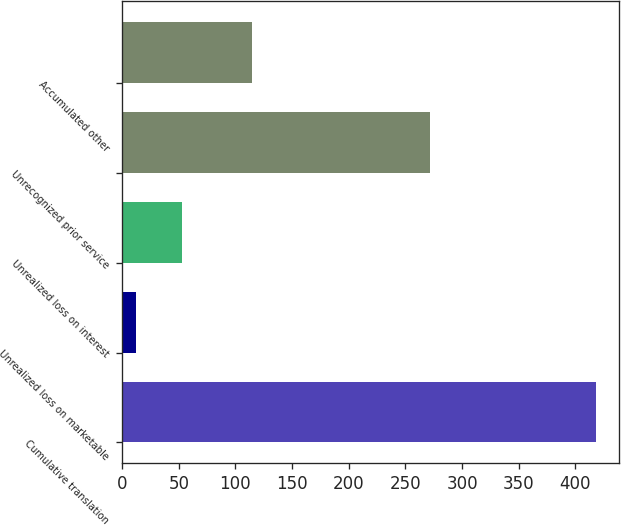Convert chart. <chart><loc_0><loc_0><loc_500><loc_500><bar_chart><fcel>Cumulative translation<fcel>Unrealized loss on marketable<fcel>Unrealized loss on interest<fcel>Unrecognized prior service<fcel>Accumulated other<nl><fcel>418<fcel>12<fcel>52.6<fcel>272<fcel>115<nl></chart> 